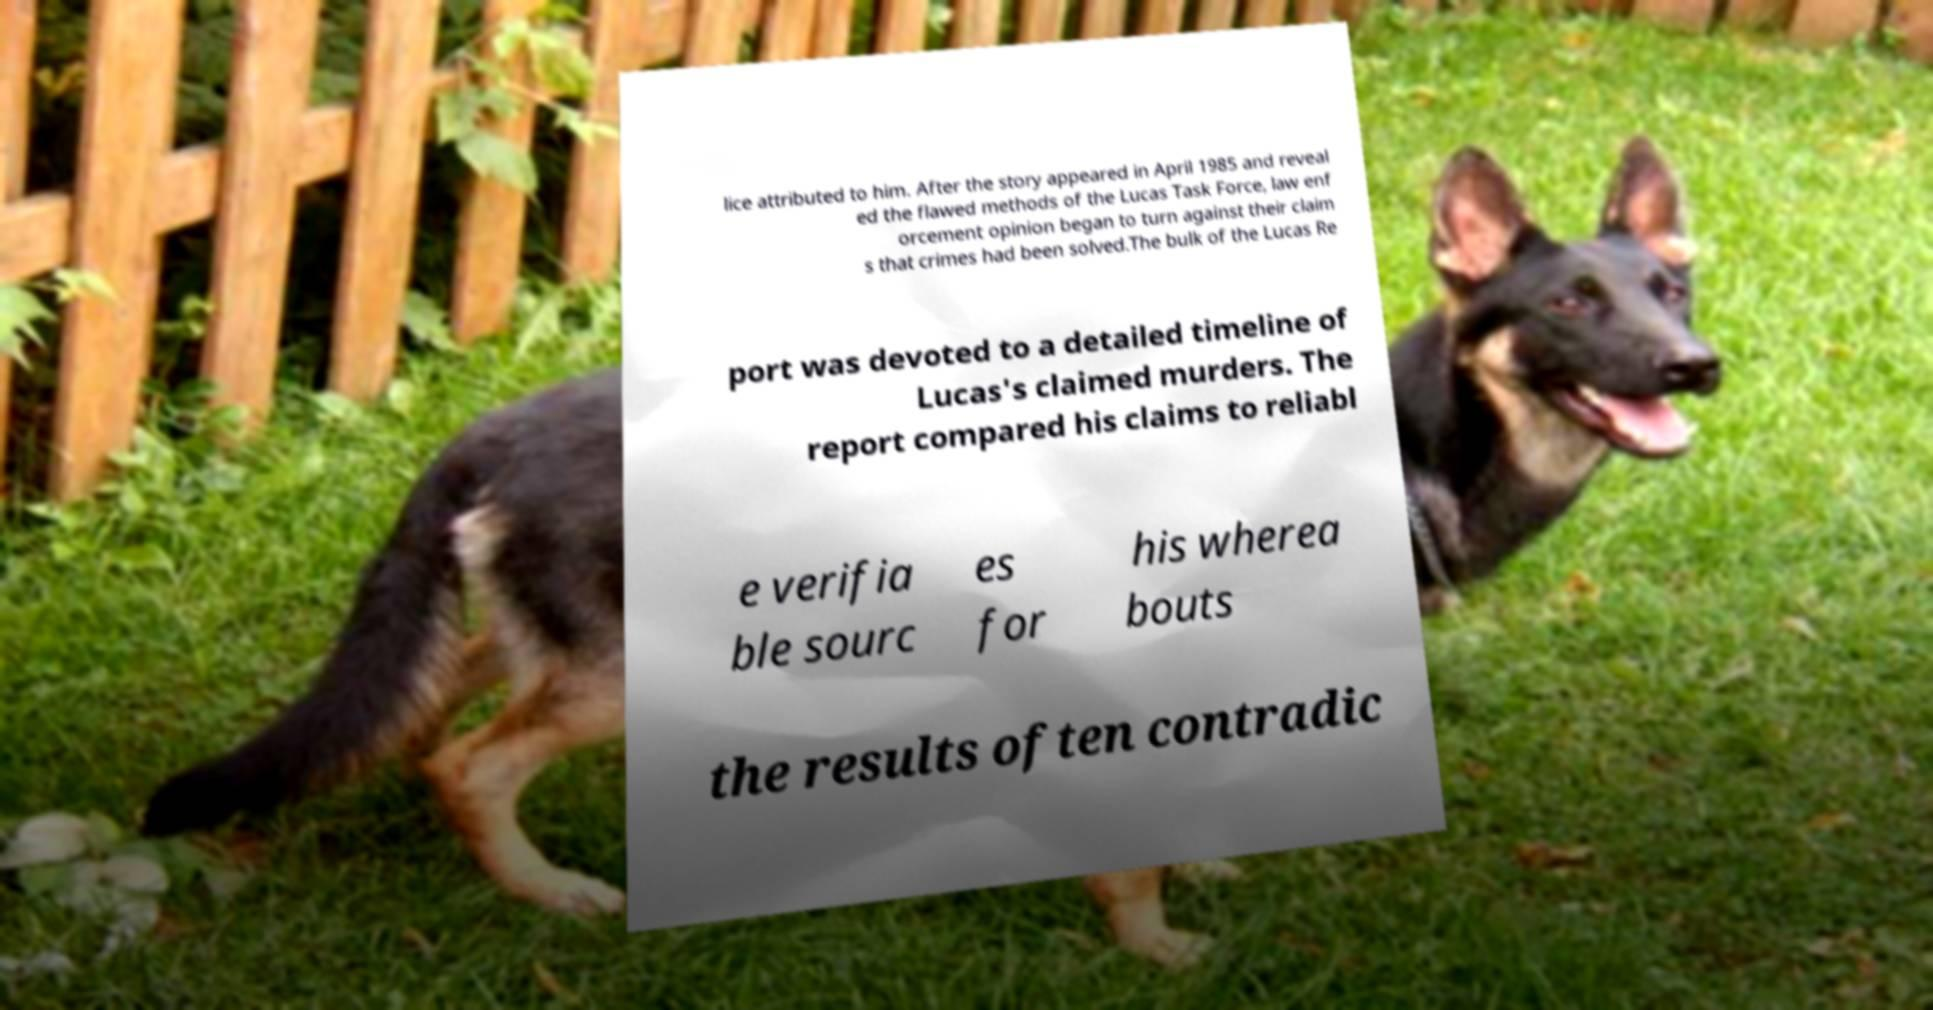Could you assist in decoding the text presented in this image and type it out clearly? lice attributed to him. After the story appeared in April 1985 and reveal ed the flawed methods of the Lucas Task Force, law enf orcement opinion began to turn against their claim s that crimes had been solved.The bulk of the Lucas Re port was devoted to a detailed timeline of Lucas's claimed murders. The report compared his claims to reliabl e verifia ble sourc es for his wherea bouts the results often contradic 